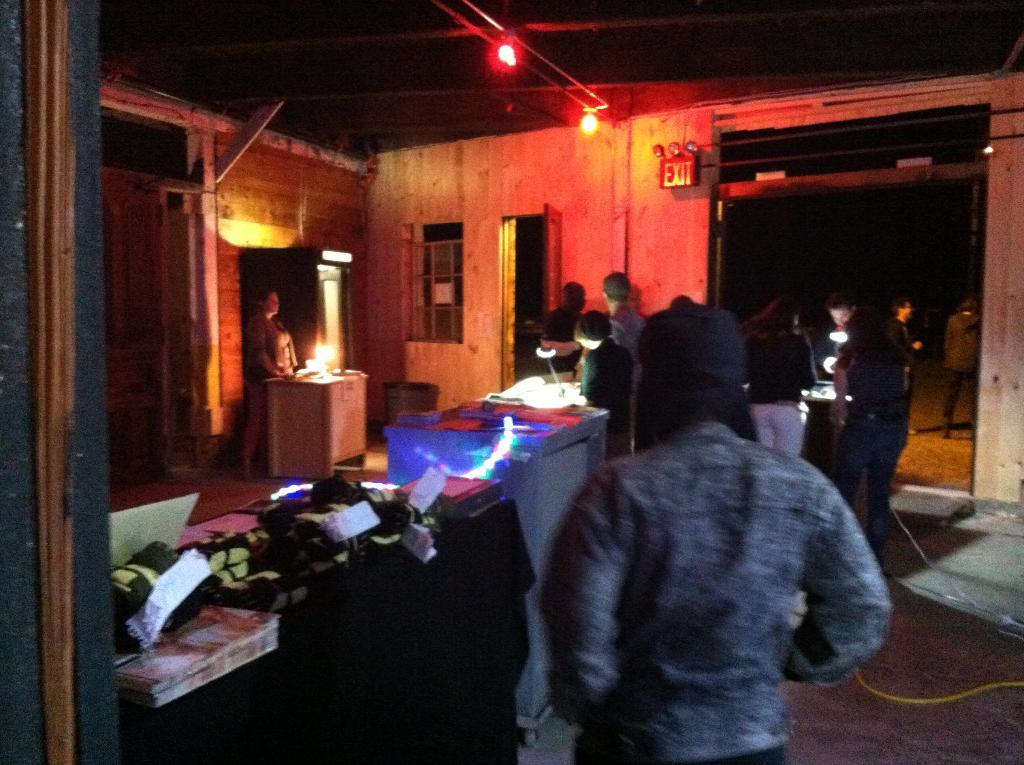How many people are in the group that is visible in the image? There is a group of people standing in the image, but the exact number cannot be determined from the provided facts. What is in front of the group of people? There are papers and objects in front of the group. What can be seen in the background of the image? There are lights and a window visible in the background. What is the color of the sky in the image? The sky appears to be black in color. What type of channel can be seen running along the edge of the image? There is no channel or edge present in the image; it features a group of people standing with papers and objects in front of them, along with lights and a window visible in the background. 